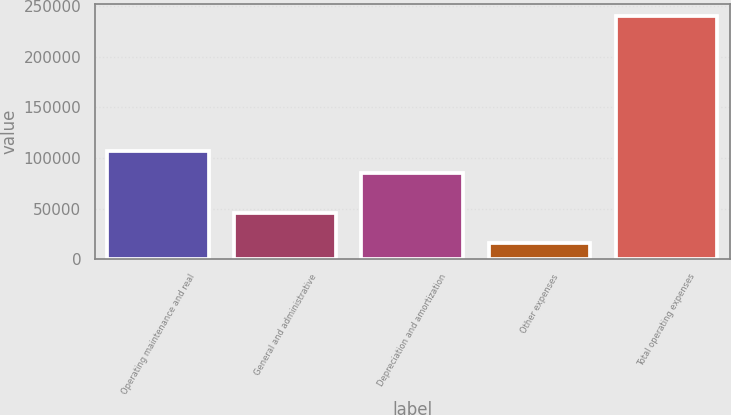Convert chart. <chart><loc_0><loc_0><loc_500><loc_500><bar_chart><fcel>Operating maintenance and real<fcel>General and administrative<fcel>Depreciation and amortization<fcel>Other expenses<fcel>Total operating expenses<nl><fcel>107153<fcel>45495<fcel>84694<fcel>15927<fcel>240521<nl></chart> 